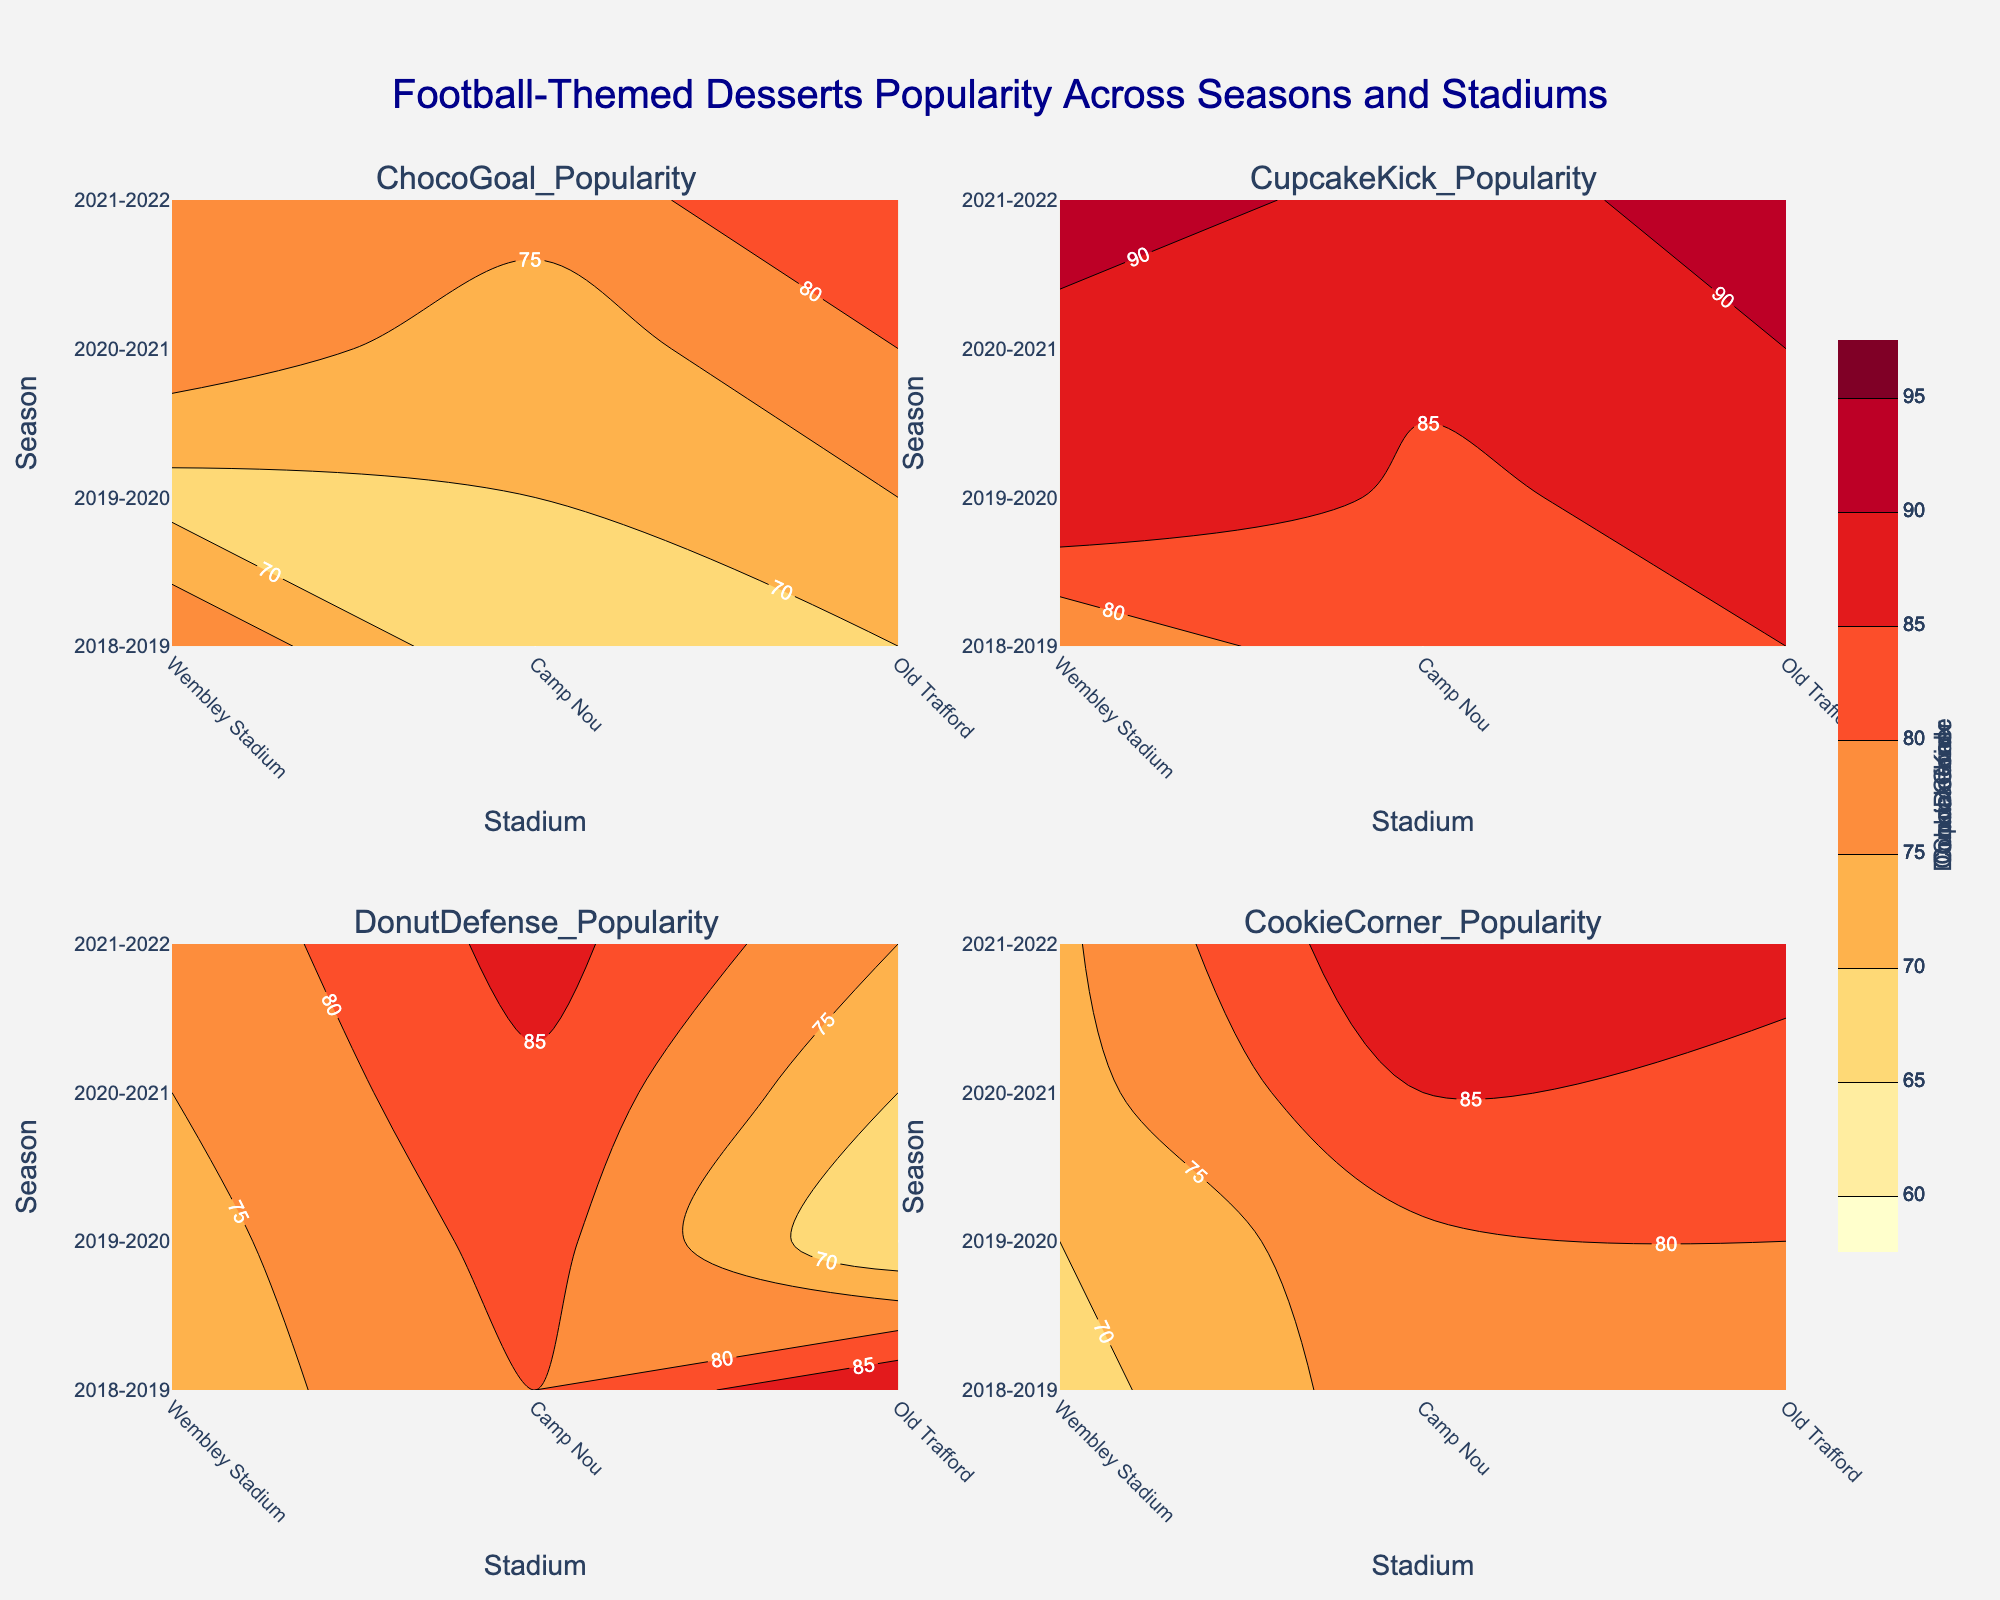What’s the title of the figure? The title of the figure is generally located at the top and is a prominent text element.
Answer: Football-Themed Desserts Popularity Across Seasons and Stadiums Which stadium had the highest popularity for ChocoGoal in the 2020-2021 season? Check the contour plot for ChocoGoal. Look for the highest contour level in the 2020-2021 row.
Answer: Wembley Stadium How did the popularity of DonutDefense in Camp Nou change from the 2018-2019 season to the 2021-2022 season? Compare the contour levels for DonutDefense at Camp Nou from 2018-2019 to 2021-2022. The levels indicate the value changes.
Answer: Increased from 72 to 76 Which dessert had the most consistent popularity across all stadiums in the 2019-2020 season? Evaluate the contour plots for each dessert during the 2019-2020 season and identify which shows the least variation across Wembley Stadium, Camp Nou, and Old Trafford.
Answer: CupcakeKick Between Wembley Stadium and Old Trafford, which stadium had a higher peak popularity for CookieCorner in the 2021-2022 season? Check the contour plot for CookieCorner in the 2021-2022 row and compare the levels between Wembley Stadium and Old Trafford.
Answer: Old Trafford During which season did Camp Nou witness the highest popularity for CupcakeKick? Locate highest contour level for CupcakeKick at Camp Nou and identify the corresponding season.
Answer: 2021-2022 Which dessert showed the greatest increase in popularity at Old Trafford from the 2018-2019 to the 2021-2022 season? For each dessert, calculate the difference between 2021-2022 and 2018-2019 levels at Old Trafford and identify the highest increase.
Answer: DonutDefense (Increase from 80 to 87) What is the average peak popularity for ChocoGoal across all stadiums in the 2020-2021 season? Extract ChocoGoal popularity values from all stadiums in 2020-2021, add them and divide by the number of stadiums. (80 + 78 + 72) / 3
Answer: 76.67 Which season had the lowest popularity for CupcakeKick across all stadiums? Find the lowest contour levels for CupcakeKick across all seasons and identify the corresponding season.
Answer: 2018-2019 For Wembley Stadium, which dessert showed the highest increase in popularity from the 2018-2019 to the 2021-2022 season? Calculate the difference for each dessert at Wembley Stadium between 2018-2019 and 2021-2022, then identify the highest increase.
Answer: CookieCorner (Increase from 75 to 88) 